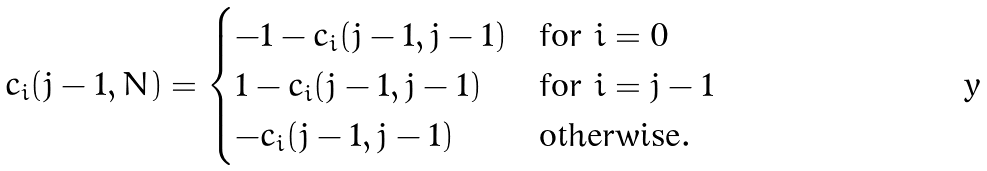Convert formula to latex. <formula><loc_0><loc_0><loc_500><loc_500>c _ { i } ( j - 1 , N ) = \begin{cases} - 1 - c _ { i } ( j - 1 , j - 1 ) & \text {for } i = 0 \\ 1 - c _ { i } ( j - 1 , j - 1 ) & \text {for } i = j - 1 \\ - c _ { i } ( j - 1 , j - 1 ) & \text {otherwise} . \end{cases}</formula> 